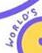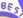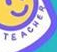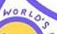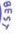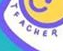Transcribe the words shown in these images in order, separated by a semicolon. WORLO'S; BES; TEACHER; WORLO'S; BEST; TEACHER 